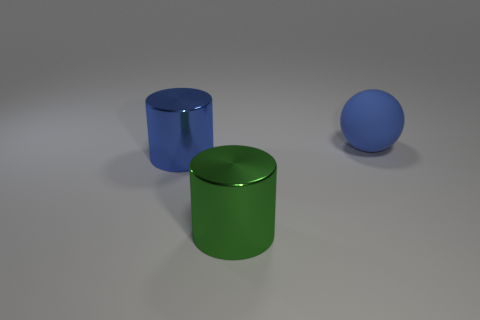Is there a large metal cylinder that has the same color as the rubber thing?
Provide a succinct answer. Yes. Are there any other things that have the same shape as the blue rubber object?
Your answer should be very brief. No. Does the large blue thing to the left of the blue ball have the same material as the large cylinder that is in front of the big blue metal cylinder?
Offer a very short reply. Yes. There is a object behind the large blue thing in front of the blue matte thing; what shape is it?
Keep it short and to the point. Sphere. There is another cylinder that is made of the same material as the large green cylinder; what color is it?
Your response must be concise. Blue. What shape is the other metallic object that is the same size as the green object?
Keep it short and to the point. Cylinder. How big is the blue matte thing?
Offer a terse response. Large. Is the size of the thing behind the blue metal cylinder the same as the blue thing in front of the blue ball?
Provide a succinct answer. Yes. There is a big metal cylinder to the right of the cylinder that is behind the big green cylinder; what is its color?
Your answer should be very brief. Green. There is a cylinder that is the same size as the green thing; what material is it?
Provide a succinct answer. Metal. 